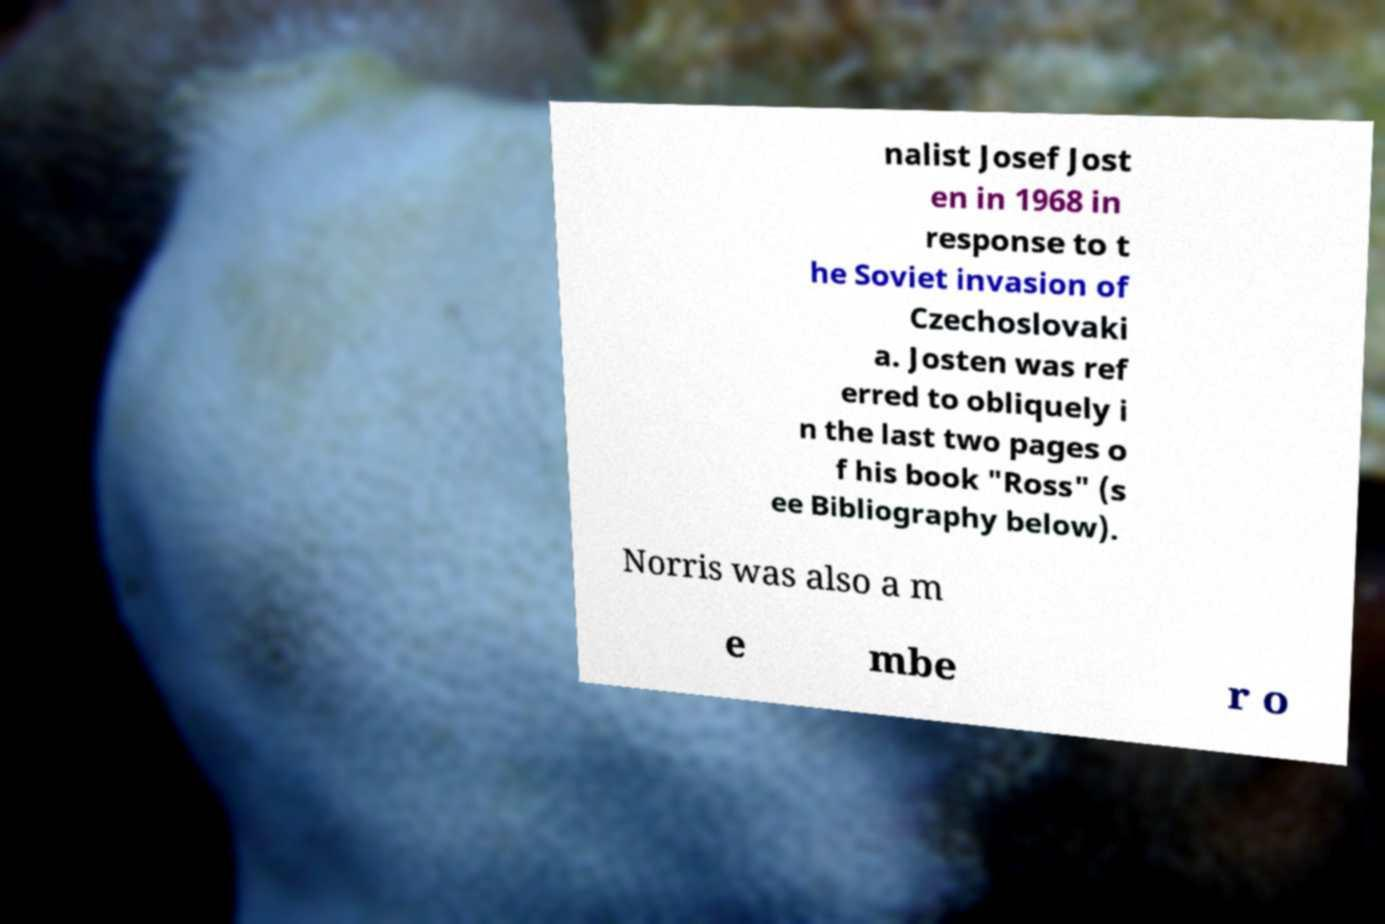Could you extract and type out the text from this image? nalist Josef Jost en in 1968 in response to t he Soviet invasion of Czechoslovaki a. Josten was ref erred to obliquely i n the last two pages o f his book "Ross" (s ee Bibliography below). Norris was also a m e mbe r o 